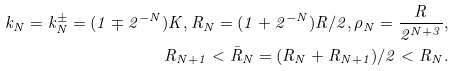<formula> <loc_0><loc_0><loc_500><loc_500>k _ { N } = k _ { N } ^ { \pm } = ( 1 \mp 2 ^ { - N } ) K , R _ { N } = ( 1 + 2 ^ { - N } ) R / 2 , \rho _ { N } = \frac { R } { 2 ^ { N + 3 } } , \\ R _ { N + 1 } < \bar { R } _ { N } = ( R _ { N } + R _ { N + 1 } ) / 2 < R _ { N } .</formula> 